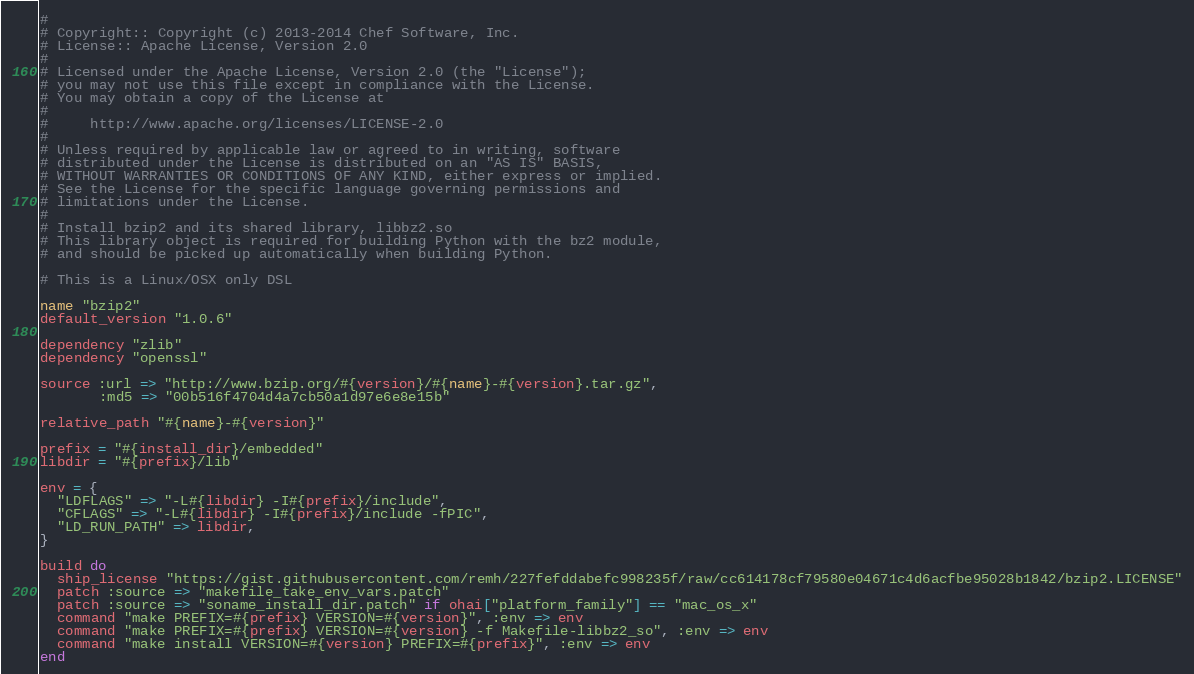Convert code to text. <code><loc_0><loc_0><loc_500><loc_500><_Ruby_>#
# Copyright:: Copyright (c) 2013-2014 Chef Software, Inc.
# License:: Apache License, Version 2.0
#
# Licensed under the Apache License, Version 2.0 (the "License");
# you may not use this file except in compliance with the License.
# You may obtain a copy of the License at
#
#     http://www.apache.org/licenses/LICENSE-2.0
#
# Unless required by applicable law or agreed to in writing, software
# distributed under the License is distributed on an "AS IS" BASIS,
# WITHOUT WARRANTIES OR CONDITIONS OF ANY KIND, either express or implied.
# See the License for the specific language governing permissions and
# limitations under the License.
#
# Install bzip2 and its shared library, libbz2.so
# This library object is required for building Python with the bz2 module,
# and should be picked up automatically when building Python.

# This is a Linux/OSX only DSL

name "bzip2"
default_version "1.0.6"

dependency "zlib"
dependency "openssl"

source :url => "http://www.bzip.org/#{version}/#{name}-#{version}.tar.gz",
       :md5 => "00b516f4704d4a7cb50a1d97e6e8e15b"

relative_path "#{name}-#{version}"

prefix = "#{install_dir}/embedded"
libdir = "#{prefix}/lib"

env = {
  "LDFLAGS" => "-L#{libdir} -I#{prefix}/include",
  "CFLAGS" => "-L#{libdir} -I#{prefix}/include -fPIC",
  "LD_RUN_PATH" => libdir,
}

build do
  ship_license "https://gist.githubusercontent.com/remh/227fefddabefc998235f/raw/cc614178cf79580e04671c4d6acfbe95028b1842/bzip2.LICENSE"
  patch :source => "makefile_take_env_vars.patch"
  patch :source => "soname_install_dir.patch" if ohai["platform_family"] == "mac_os_x"
  command "make PREFIX=#{prefix} VERSION=#{version}", :env => env
  command "make PREFIX=#{prefix} VERSION=#{version} -f Makefile-libbz2_so", :env => env
  command "make install VERSION=#{version} PREFIX=#{prefix}", :env => env
end
</code> 